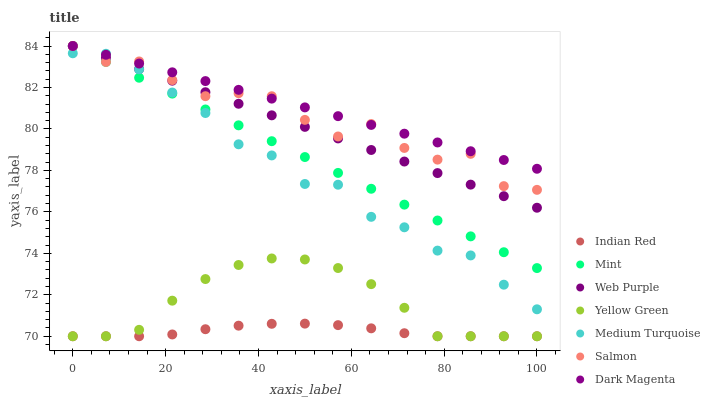Does Indian Red have the minimum area under the curve?
Answer yes or no. Yes. Does Dark Magenta have the maximum area under the curve?
Answer yes or no. Yes. Does Yellow Green have the minimum area under the curve?
Answer yes or no. No. Does Yellow Green have the maximum area under the curve?
Answer yes or no. No. Is Dark Magenta the smoothest?
Answer yes or no. Yes. Is Salmon the roughest?
Answer yes or no. Yes. Is Yellow Green the smoothest?
Answer yes or no. No. Is Yellow Green the roughest?
Answer yes or no. No. Does Yellow Green have the lowest value?
Answer yes or no. Yes. Does Salmon have the lowest value?
Answer yes or no. No. Does Dark Magenta have the highest value?
Answer yes or no. Yes. Does Yellow Green have the highest value?
Answer yes or no. No. Is Yellow Green less than Medium Turquoise?
Answer yes or no. Yes. Is Web Purple greater than Yellow Green?
Answer yes or no. Yes. Does Salmon intersect Dark Magenta?
Answer yes or no. Yes. Is Salmon less than Dark Magenta?
Answer yes or no. No. Is Salmon greater than Dark Magenta?
Answer yes or no. No. Does Yellow Green intersect Medium Turquoise?
Answer yes or no. No. 